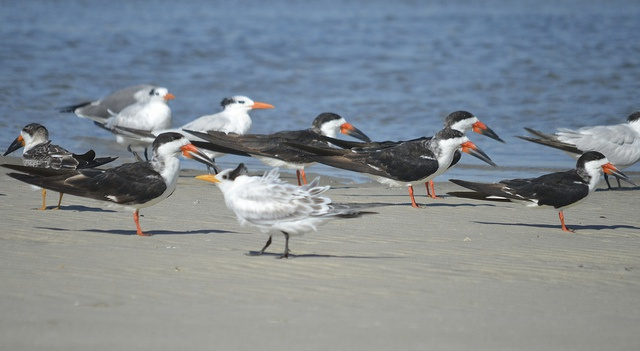Describe the objects in this image and their specific colors. I can see bird in gray, black, darkgray, and lightgray tones, bird in gray, lightgray, and darkgray tones, bird in gray, black, darkgray, and lightgray tones, bird in gray, black, darkgray, and lightgray tones, and bird in gray, black, darkgray, and lightgray tones in this image. 